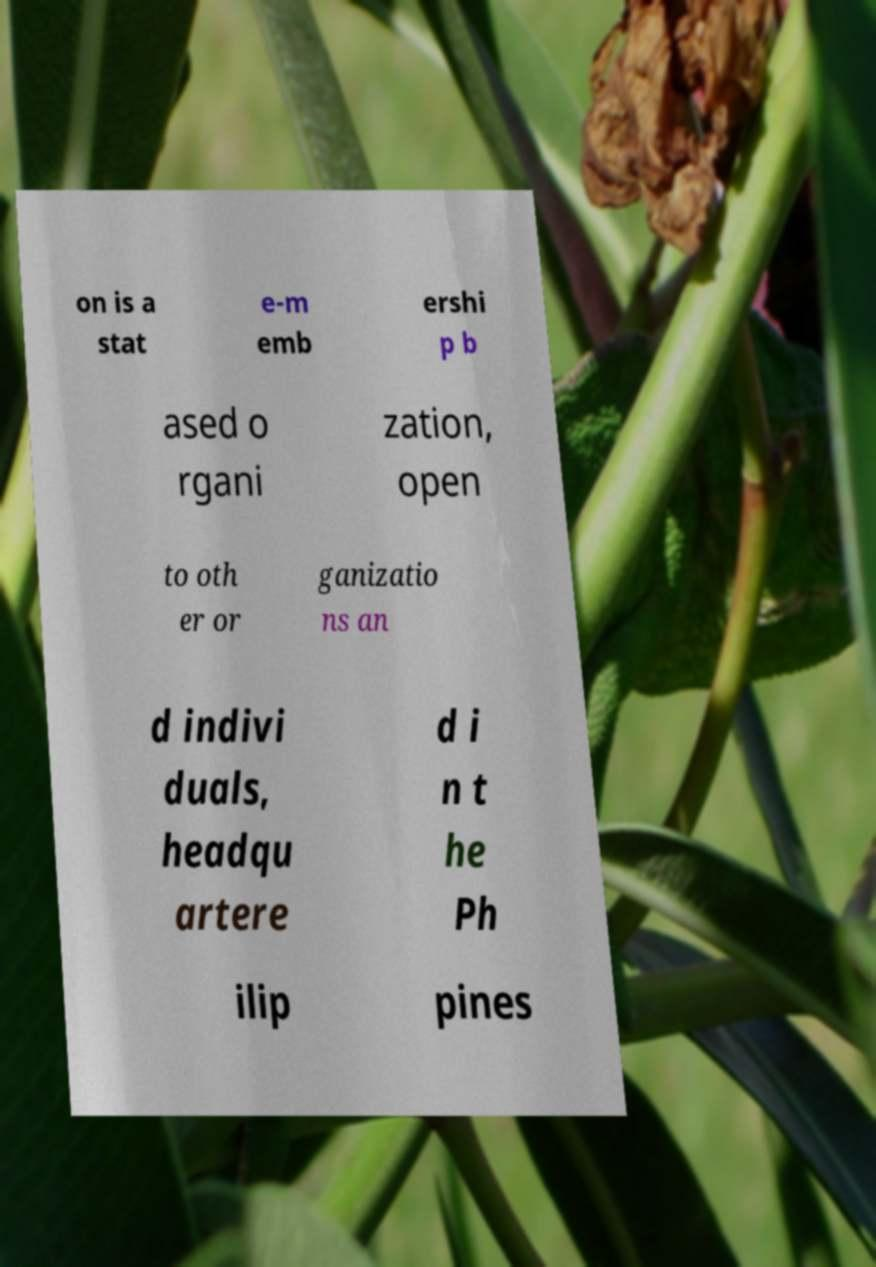Can you read and provide the text displayed in the image?This photo seems to have some interesting text. Can you extract and type it out for me? on is a stat e-m emb ershi p b ased o rgani zation, open to oth er or ganizatio ns an d indivi duals, headqu artere d i n t he Ph ilip pines 